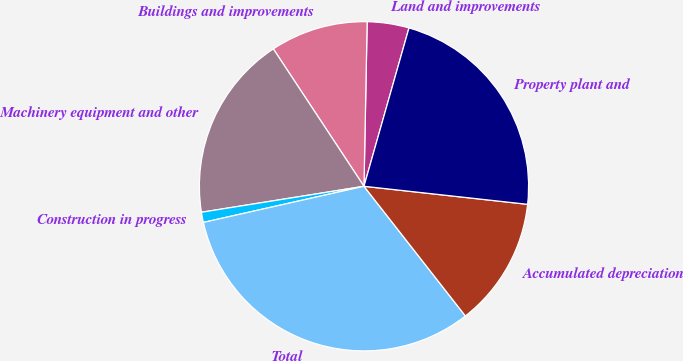Convert chart to OTSL. <chart><loc_0><loc_0><loc_500><loc_500><pie_chart><fcel>Land and improvements<fcel>Buildings and improvements<fcel>Machinery equipment and other<fcel>Construction in progress<fcel>Total<fcel>Accumulated depreciation<fcel>Property plant and<nl><fcel>4.1%<fcel>9.59%<fcel>18.24%<fcel>1.0%<fcel>32.04%<fcel>12.69%<fcel>22.34%<nl></chart> 